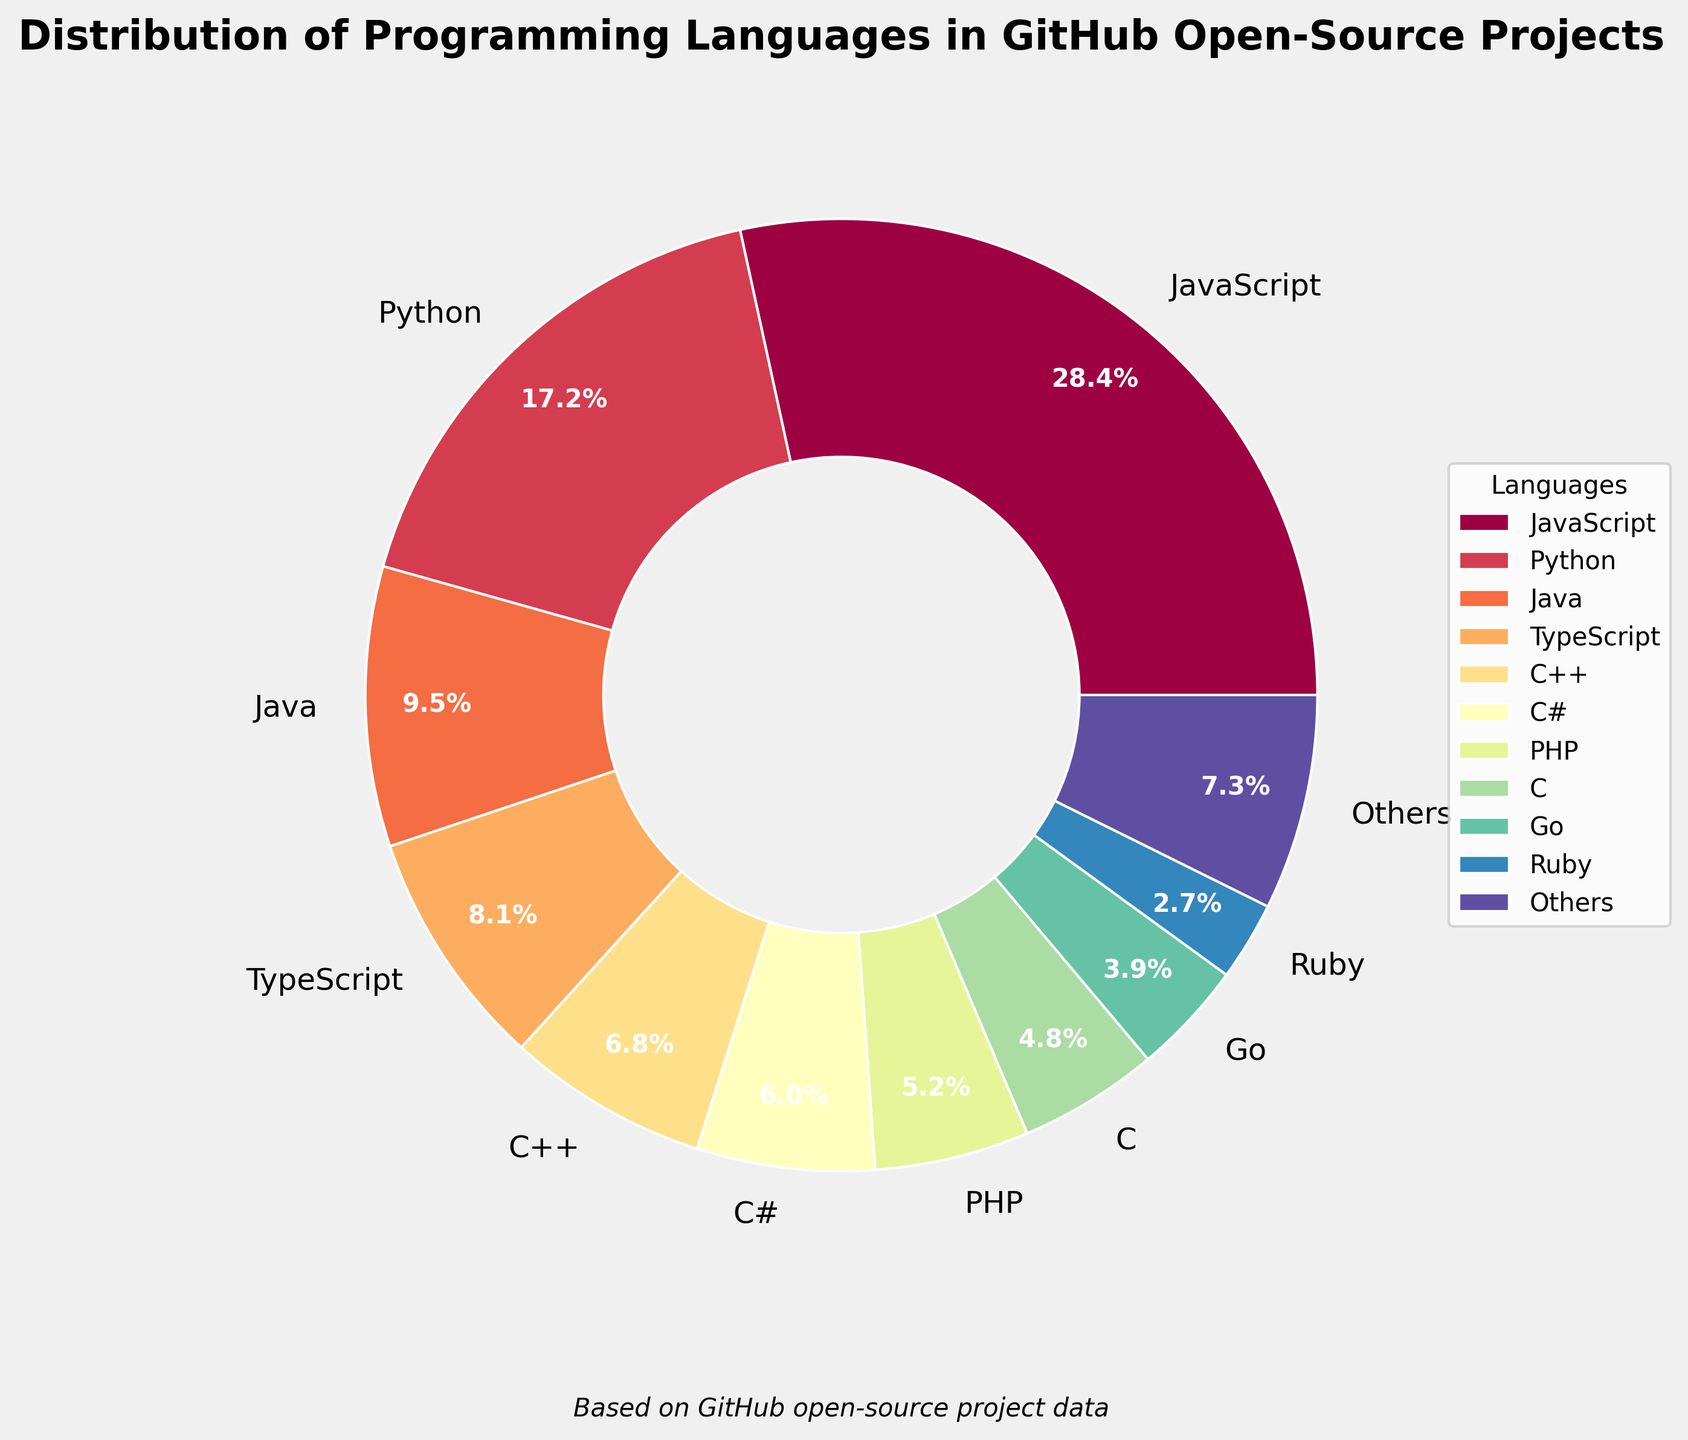Which programming language is used the most in GitHub open-source projects? The figure shows JavaScript having the largest slice of the pie chart. By examining the corresponding label, it can be seen that JavaScript holds the highest percentage.
Answer: JavaScript How does the usage percentage of Python compare to JavaScript in open-source projects on GitHub? JavaScript is labeled with 28.7% and Python with 17.4%. Thus, JavaScript is used more than Python.
Answer: JavaScript > Python What is the total percentage of the top 5 programming languages? The top 5 programming languages and their percentages are JavaScript (28.7%), Python (17.4%), Java (9.6%), TypeScript (8.2%), and C++ (6.9%). Adding these percentages together: 28.7 + 17.4 + 9.6 + 8.2 + 6.9 = 70.8%.
Answer: 70.8% Which language category is depicted with the smallest percentage in the pie chart? The smallest labeled wedge in the pie chart is "Others", which aggregates all languages outside the top 10.
Answer: Others What percentage of the pie chart is represented by the "Others" category? The pie chart includes the label "Others", which is the smallest slice, and from the data, we know the sum of percentages of the languages outside the top 10 is aggregated here. The chart shows this category representing a certain percentage, calculated as the sum of all percentages minus the top 10.
Answer: (% value from pie chart) Among the top 10 languages, which one has the least usage percentage in GitHub open-source projects? By examining the pie slices of the top 10 languages, the smallest slice among them is Ruby at 2.7%.
Answer: Ruby Combine the usage percentages of C++, C#, and PHP. What is the sum? The percentages are: C++ (6.9%), C# (6.1%), and PHP (5.3%). Adding these together: 6.9 + 6.1 + 5.3 = 18.3%.
Answer: 18.3% Is Go used more or less than PHP in GitHub open-source projects? Go is labeled with 3.9% while PHP has 5.3%, indicating Go is used less than PHP.
Answer: Go < PHP What are the percentages for C and Go together? The percentages for C and Go are 4.8% and 3.9%, respectively. Adding them together: 4.8 + 3.9 = 8.7%.
Answer: 8.7% Which languages have a usage percentage above 5%? By inspecting the slices in the pie chart corresponding to percentages above 5%, the languages are JavaScript (28.7%), Python (17.4%), Java (9.6%), TypeScript (8.2%), C++ (6.9%), and C# (6.1%).
Answer: JavaScript, Python, Java, TypeScript, C++, C# 